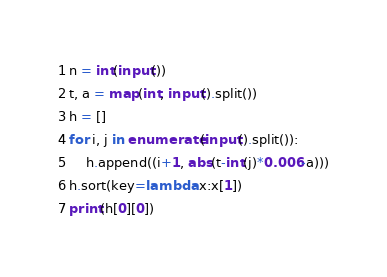<code> <loc_0><loc_0><loc_500><loc_500><_Python_>n = int(input())
t, a = map(int, input().split())
h = []
for i, j in enumerate(input().split()):
    h.append((i+1, abs(t-int(j)*0.006-a)))
h.sort(key=lambda x:x[1])
print(h[0][0])</code> 